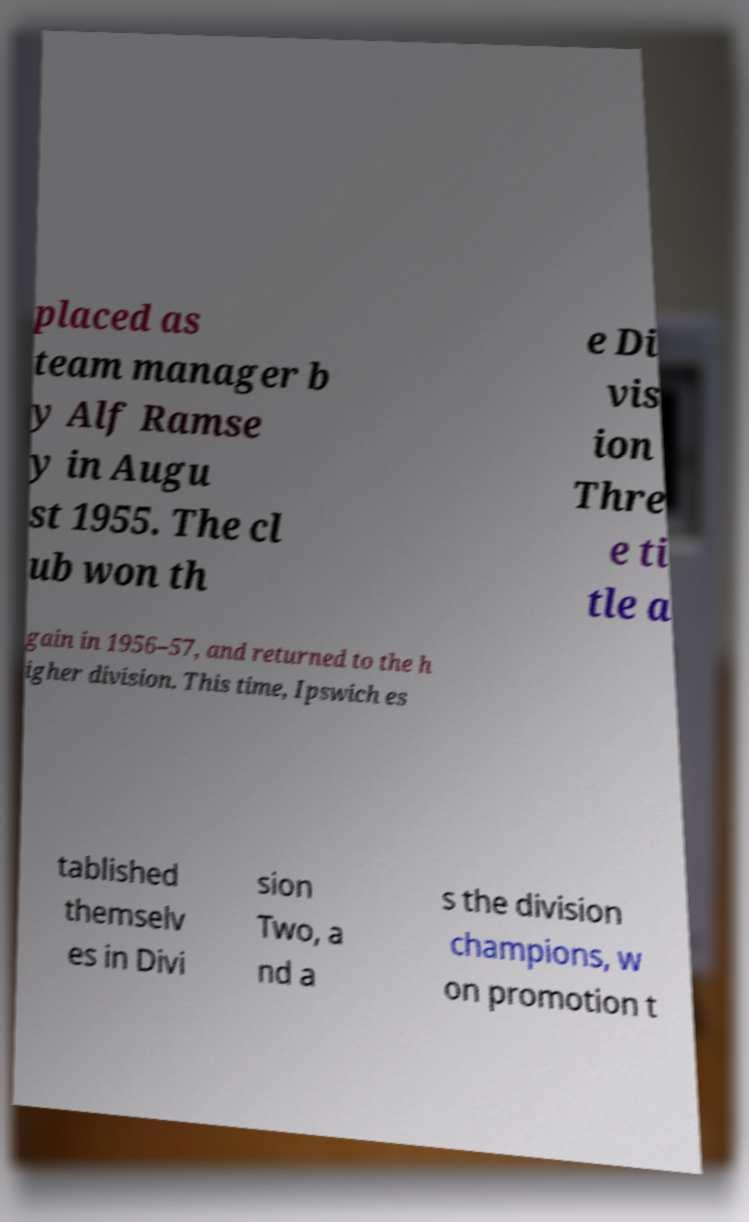For documentation purposes, I need the text within this image transcribed. Could you provide that? placed as team manager b y Alf Ramse y in Augu st 1955. The cl ub won th e Di vis ion Thre e ti tle a gain in 1956–57, and returned to the h igher division. This time, Ipswich es tablished themselv es in Divi sion Two, a nd a s the division champions, w on promotion t 